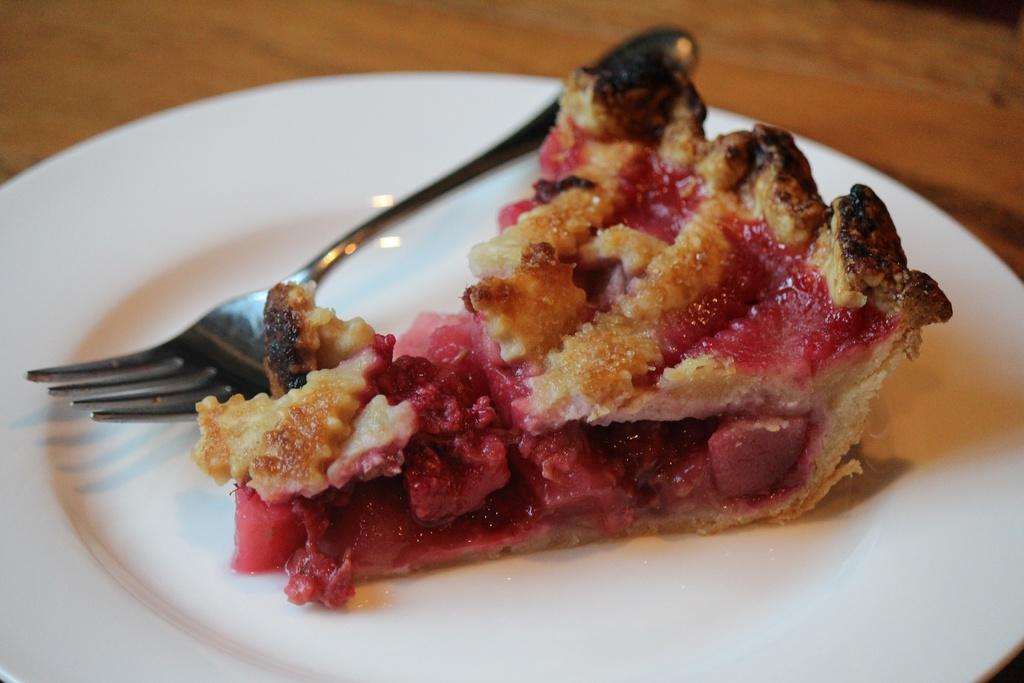What is the main object in the image? There is a wooden plank in the image. What is placed on the wooden plank? There is a white color plate on the wooden plank. What is on the plate? There is a food item on the plate. What utensil is beside the food item? There is a fork beside the food item. How many people are laughing at the joke in the image? There is no joke or crowd present in the image; it features a wooden plank with a plate, food item, and fork. Where is the mailbox located in the image? There is no mailbox present in the image. 